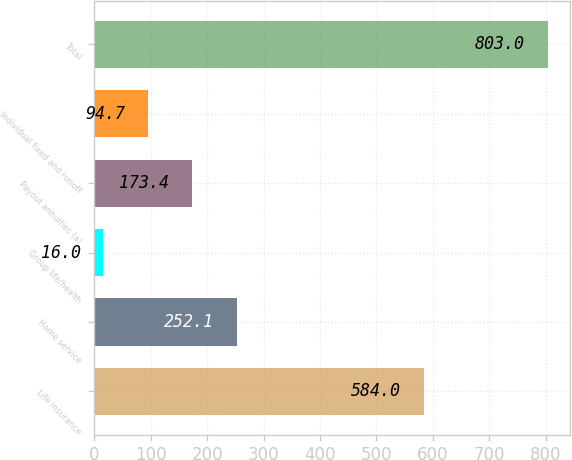Convert chart to OTSL. <chart><loc_0><loc_0><loc_500><loc_500><bar_chart><fcel>Life insurance<fcel>Home service<fcel>Group life/health<fcel>Payout annuities (a)<fcel>Individual fixed and runoff<fcel>Total<nl><fcel>584<fcel>252.1<fcel>16<fcel>173.4<fcel>94.7<fcel>803<nl></chart> 